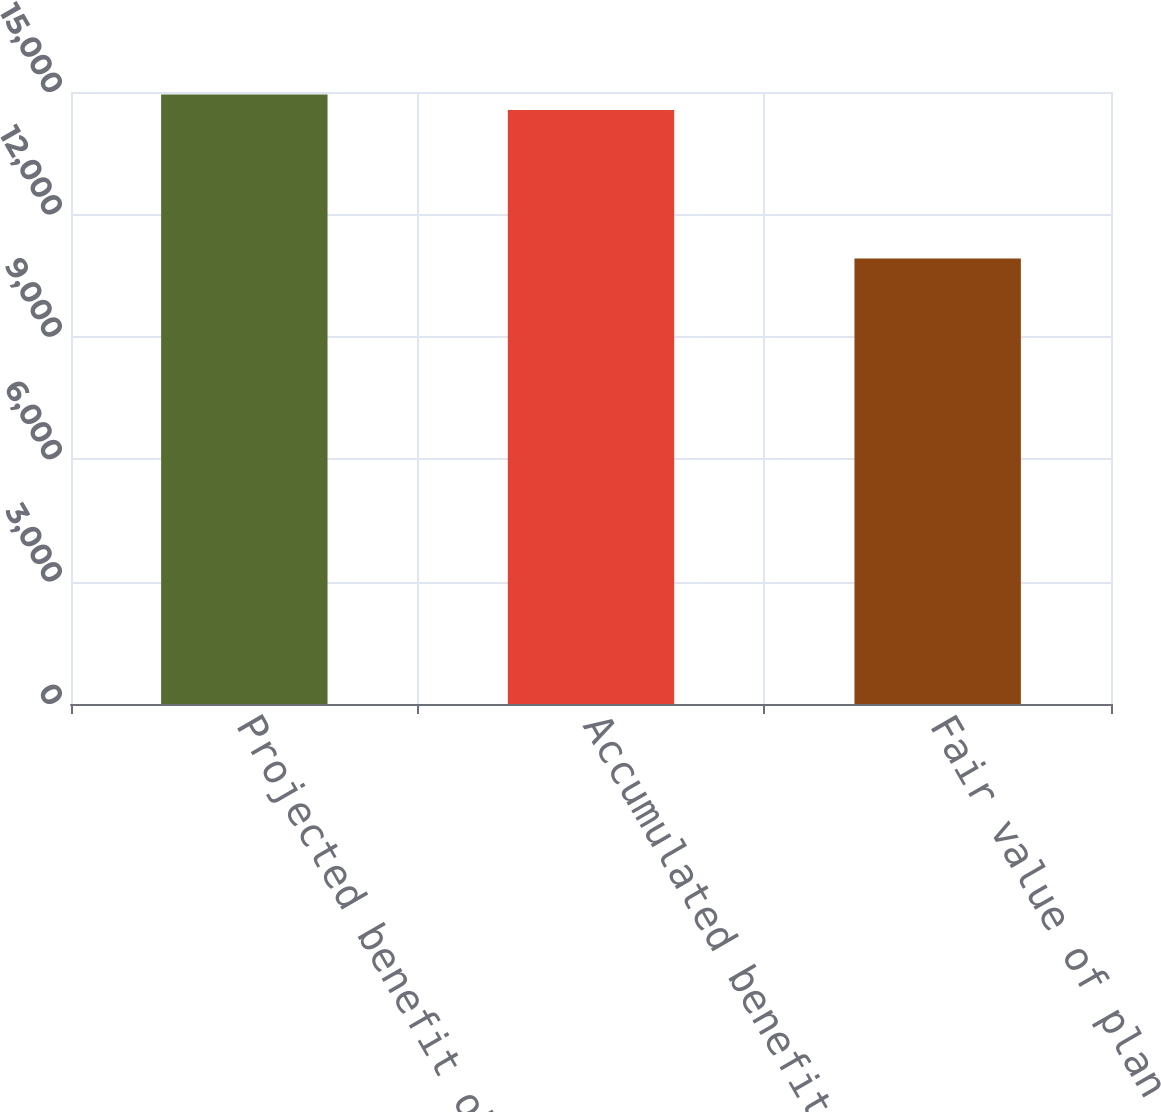Convert chart to OTSL. <chart><loc_0><loc_0><loc_500><loc_500><bar_chart><fcel>Projected benefit obligation<fcel>Accumulated benefit obligation<fcel>Fair value of plan assets<nl><fcel>14941.3<fcel>14559<fcel>10918<nl></chart> 